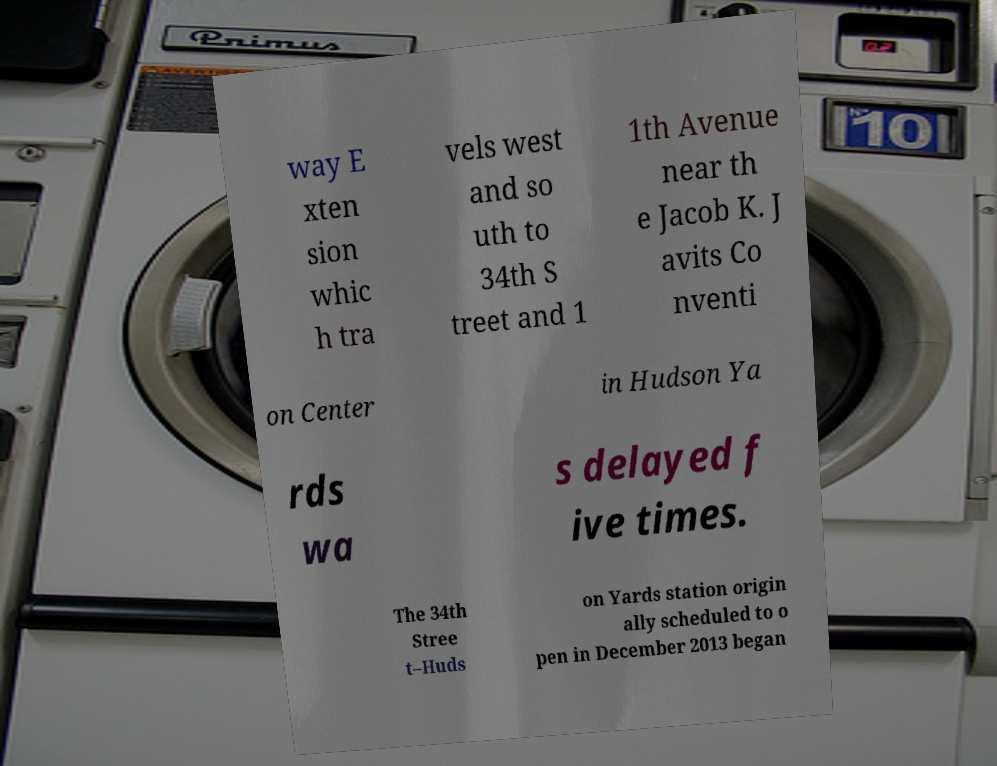Please identify and transcribe the text found in this image. way E xten sion whic h tra vels west and so uth to 34th S treet and 1 1th Avenue near th e Jacob K. J avits Co nventi on Center in Hudson Ya rds wa s delayed f ive times. The 34th Stree t–Huds on Yards station origin ally scheduled to o pen in December 2013 began 